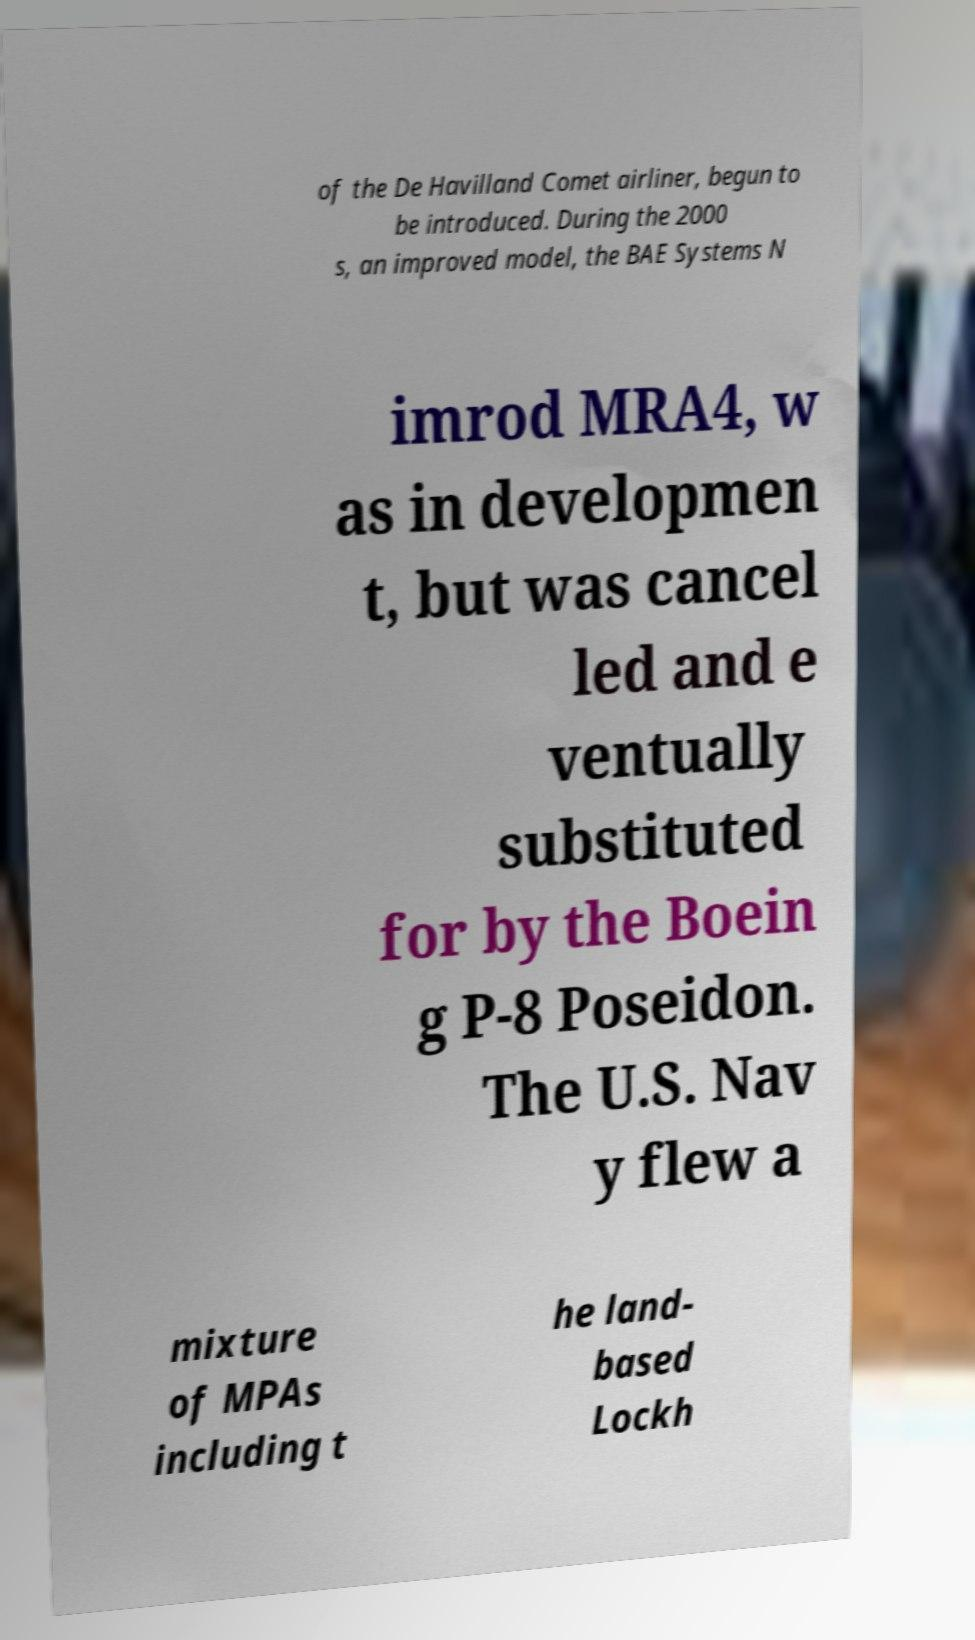I need the written content from this picture converted into text. Can you do that? of the De Havilland Comet airliner, begun to be introduced. During the 2000 s, an improved model, the BAE Systems N imrod MRA4, w as in developmen t, but was cancel led and e ventually substituted for by the Boein g P-8 Poseidon. The U.S. Nav y flew a mixture of MPAs including t he land- based Lockh 